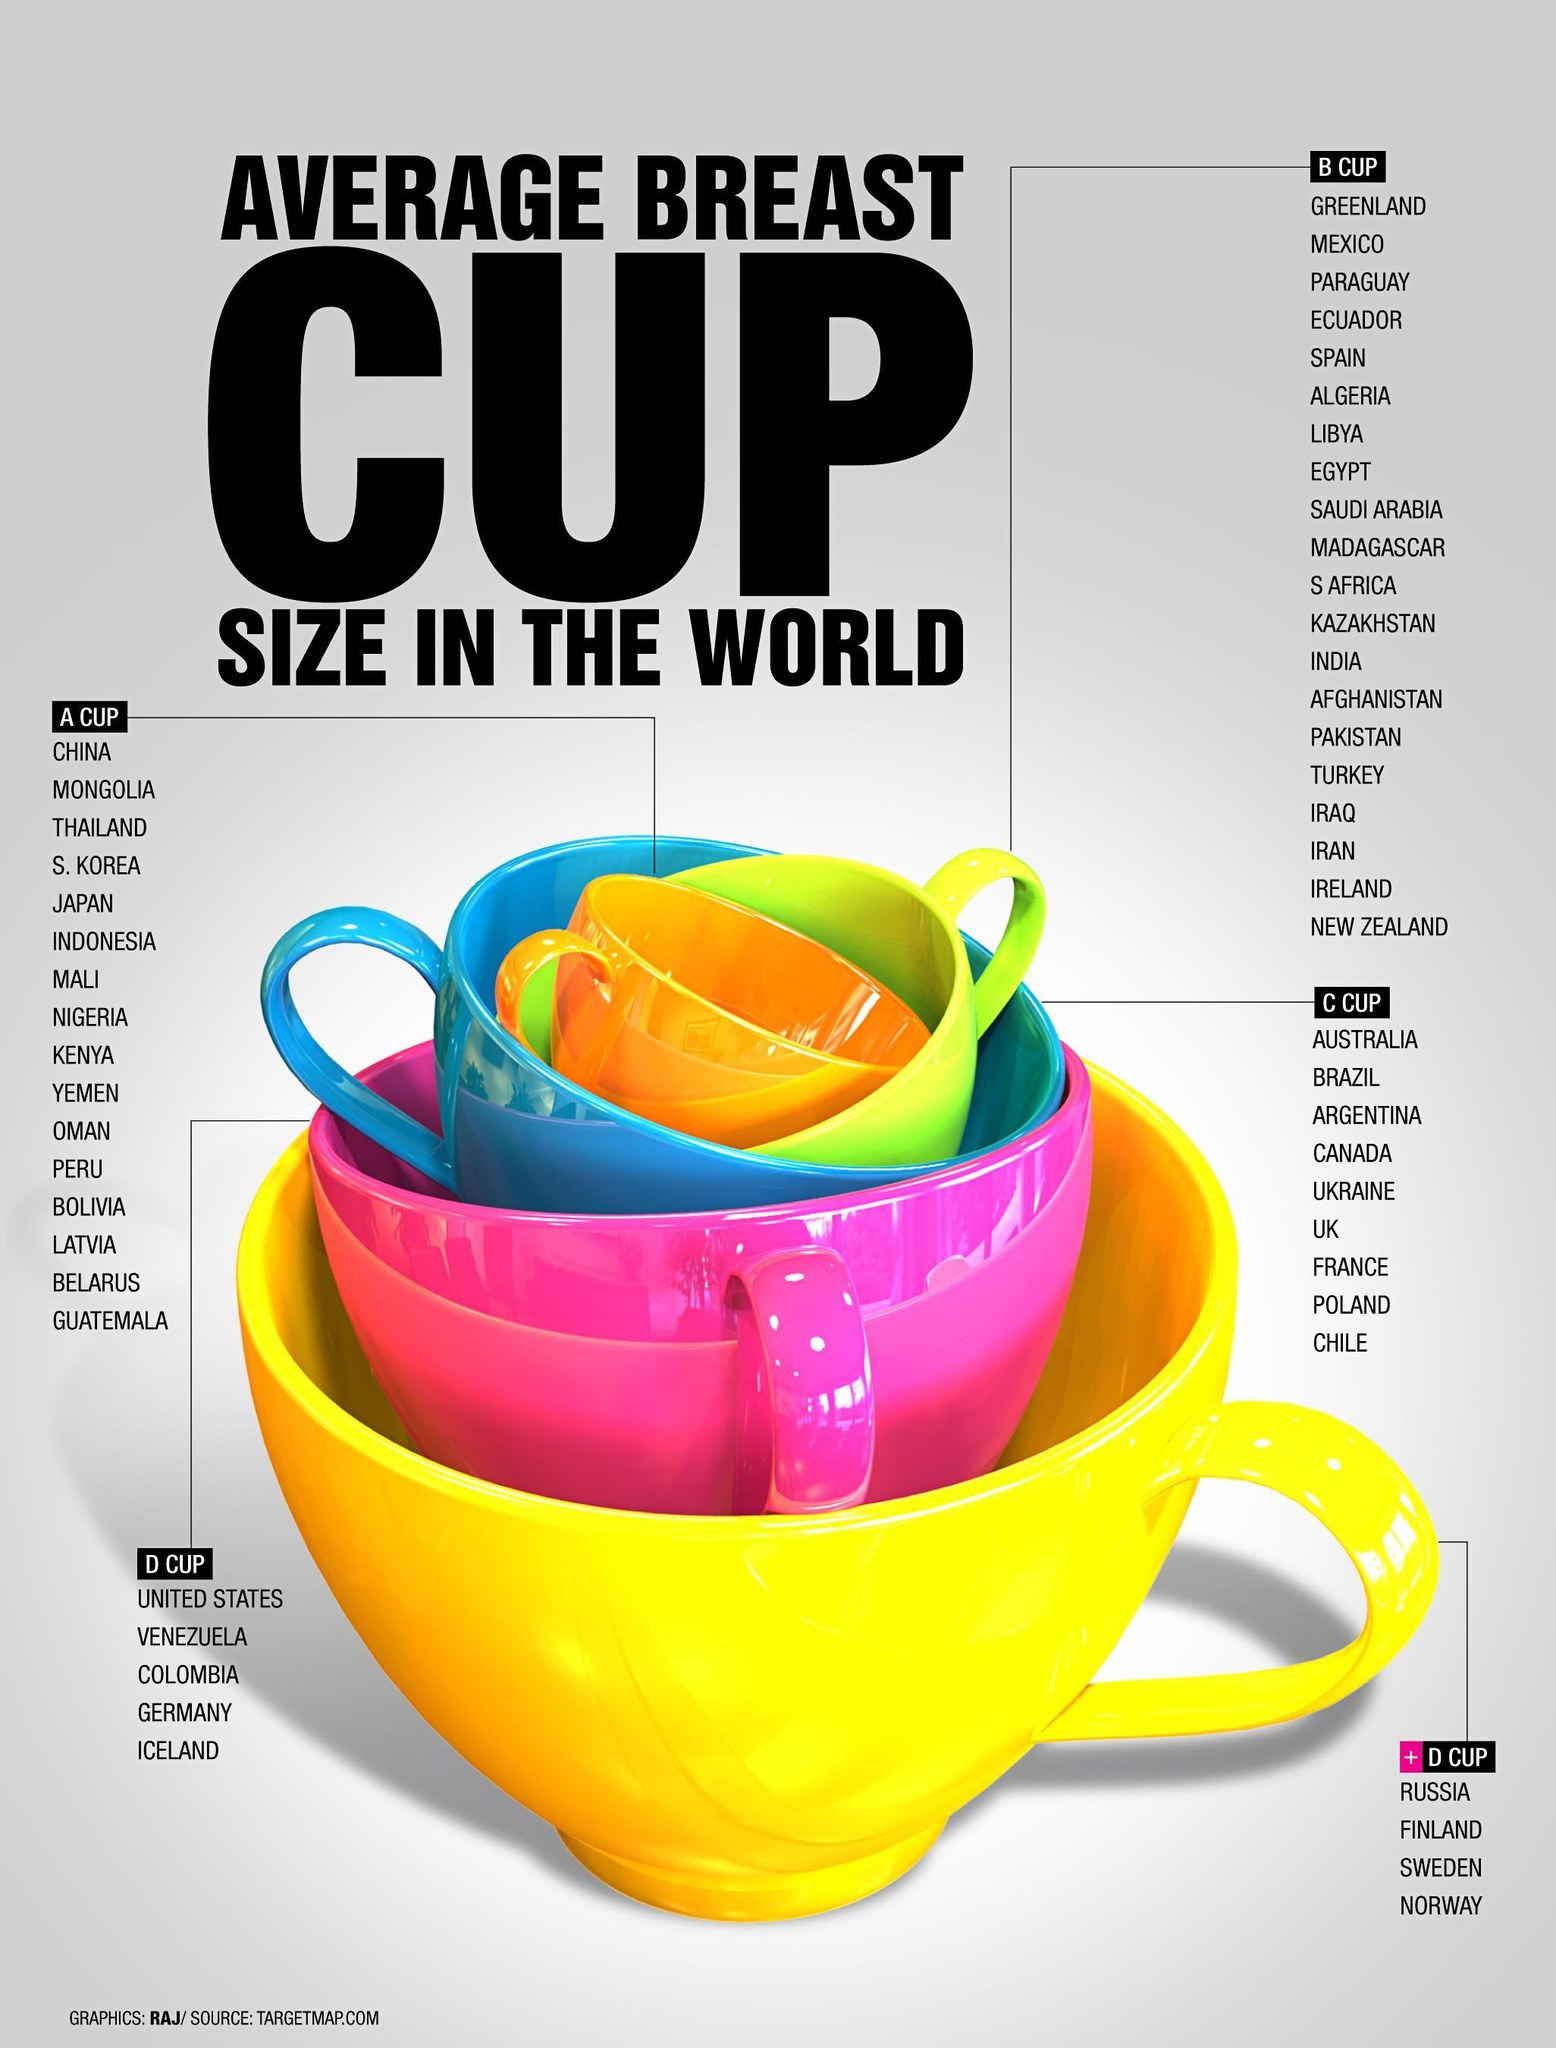The pink cup in the image represents which size?
Answer the question with a short phrase. D CUP In which cup size category is Pakistan listed? B CUP In the image, what is the color of the cup representing size A- yellow, blue or orange? orange Which the second country listed under the cup size represented by the yellow cup? FINLAND What is the color of the second biggest cup shown in the image - yellow, pink or blue? pink Which is the second last country listed under the cup size represented by the green cup? IRELAND How many countries are listed under the cup size represented by the blue cup? 9 